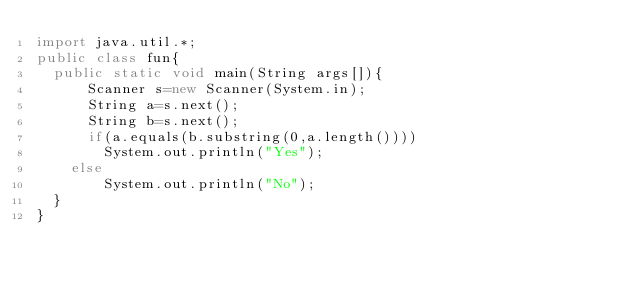Convert code to text. <code><loc_0><loc_0><loc_500><loc_500><_Java_>import java.util.*;
public class fun{
  public static void main(String args[]){
      Scanner s=new Scanner(System.in);
      String a=s.next();
      String b=s.next();
      if(a.equals(b.substring(0,a.length())))
        System.out.println("Yes");
    else
        System.out.println("No");
  }
}</code> 